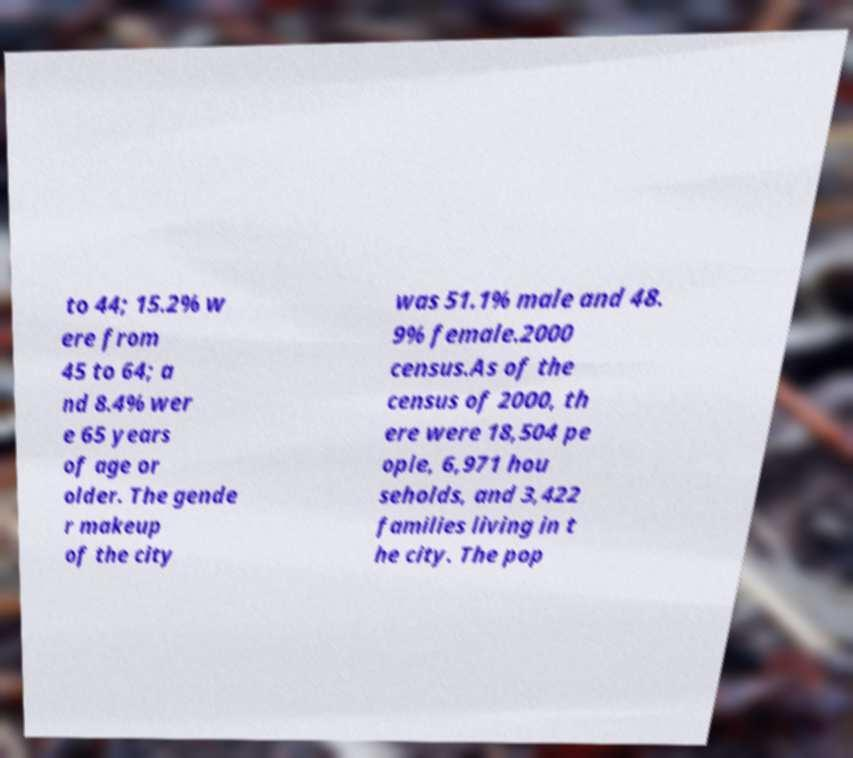Please read and relay the text visible in this image. What does it say? to 44; 15.2% w ere from 45 to 64; a nd 8.4% wer e 65 years of age or older. The gende r makeup of the city was 51.1% male and 48. 9% female.2000 census.As of the census of 2000, th ere were 18,504 pe ople, 6,971 hou seholds, and 3,422 families living in t he city. The pop 